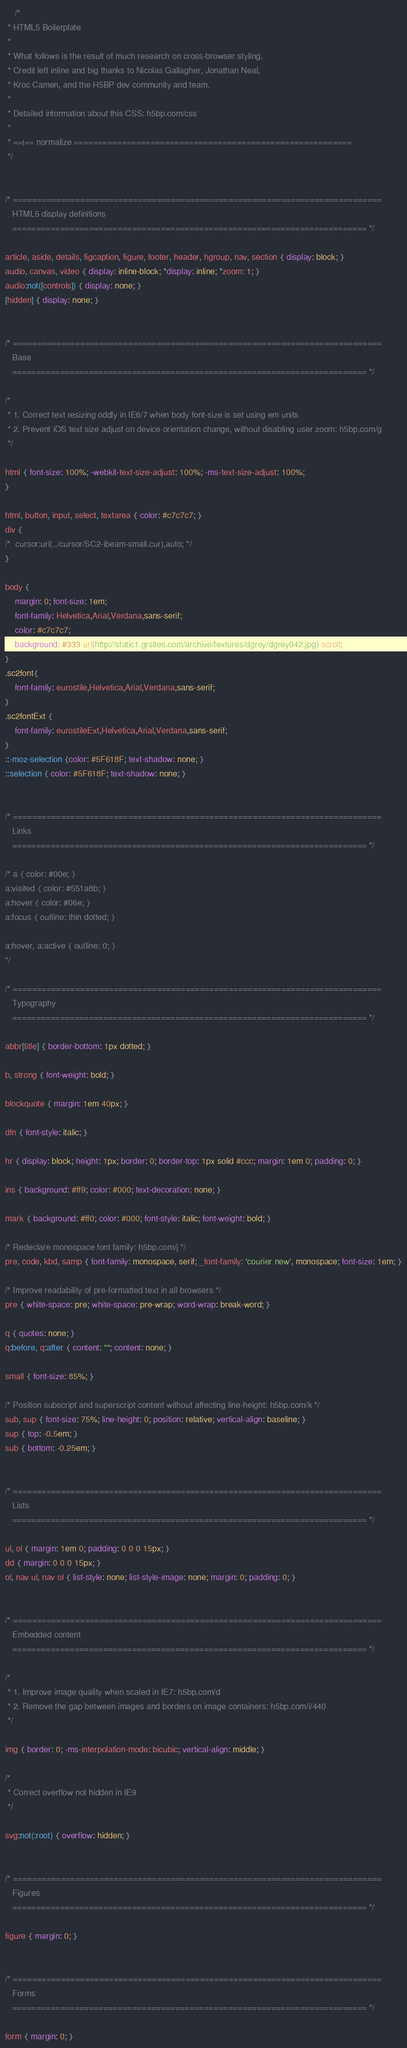Convert code to text. <code><loc_0><loc_0><loc_500><loc_500><_CSS_>	/*
 * HTML5 Boilerplate
 *
 * What follows is the result of much research on cross-browser styling.
 * Credit left inline and big thanks to Nicolas Gallagher, Jonathan Neal,
 * Kroc Camen, and the H5BP dev community and team.
 *
 * Detailed information about this CSS: h5bp.com/css
 *
 * ==|== normalize ==========================================================
 */


/* =============================================================================
   HTML5 display definitions
   ========================================================================== */

article, aside, details, figcaption, figure, footer, header, hgroup, nav, section { display: block; }
audio, canvas, video { display: inline-block; *display: inline; *zoom: 1; }
audio:not([controls]) { display: none; }
[hidden] { display: none; }


/* =============================================================================
   Base
   ========================================================================== */

/*
 * 1. Correct text resizing oddly in IE6/7 when body font-size is set using em units
 * 2. Prevent iOS text size adjust on device orientation change, without disabling user zoom: h5bp.com/g
 */

html { font-size: 100%; -webkit-text-size-adjust: 100%; -ms-text-size-adjust: 100%; 
}

html, button, input, select, textarea { color: #c7c7c7; }
div {
/*	cursor:url(../cursor/SC2-ibeam-small.cur),auto; */
}

body { 
	margin: 0; font-size: 1em; 
	font-family: Helvetica,Arial,Verdana,sans-serif;
	color: #c7c7c7;
	background: #333 url(http://static1.grsites.com/archive/textures/dgrey/dgrey042.jpg) scroll;
}
.sc2font{
	font-family: eurostile,Helvetica,Arial,Verdana,sans-serif;
}
.sc2fontExt {
	font-family: eurostileExt,Helvetica,Arial,Verdana,sans-serif;
}
::-moz-selection {color: #5F618F; text-shadow: none; }
::selection { color: #5F618F; text-shadow: none; }


/* =============================================================================
   Links
   ========================================================================== */

/* a { color: #00e; } 
a:visited { color: #551a8b; }
a:hover { color: #06e; }
a:focus { outline: thin dotted; }

a:hover, a:active { outline: 0; }
*/

/* =============================================================================
   Typography
   ========================================================================== */

abbr[title] { border-bottom: 1px dotted; }

b, strong { font-weight: bold; }

blockquote { margin: 1em 40px; }

dfn { font-style: italic; }

hr { display: block; height: 1px; border: 0; border-top: 1px solid #ccc; margin: 1em 0; padding: 0; }

ins { background: #ff9; color: #000; text-decoration: none; }

mark { background: #ff0; color: #000; font-style: italic; font-weight: bold; }

/* Redeclare monospace font family: h5bp.com/j */
pre, code, kbd, samp { font-family: monospace, serif; _font-family: 'courier new', monospace; font-size: 1em; }

/* Improve readability of pre-formatted text in all browsers */
pre { white-space: pre; white-space: pre-wrap; word-wrap: break-word; }

q { quotes: none; }
q:before, q:after { content: ""; content: none; }

small { font-size: 85%; }

/* Position subscript and superscript content without affecting line-height: h5bp.com/k */
sub, sup { font-size: 75%; line-height: 0; position: relative; vertical-align: baseline; }
sup { top: -0.5em; }
sub { bottom: -0.25em; }


/* =============================================================================
   Lists
   ========================================================================== */

ul, ol { margin: 1em 0; padding: 0 0 0 15px; }
dd { margin: 0 0 0 15px; }
ol, nav ul, nav ol { list-style: none; list-style-image: none; margin: 0; padding: 0; }


/* =============================================================================
   Embedded content
   ========================================================================== */

/*
 * 1. Improve image quality when scaled in IE7: h5bp.com/d
 * 2. Remove the gap between images and borders on image containers: h5bp.com/i/440
 */

img { border: 0; -ms-interpolation-mode: bicubic; vertical-align: middle; }

/*
 * Correct overflow not hidden in IE9
 */

svg:not(:root) { overflow: hidden; }


/* =============================================================================
   Figures
   ========================================================================== */

figure { margin: 0; }


/* =============================================================================
   Forms
   ========================================================================== */

form { margin: 0; }</code> 